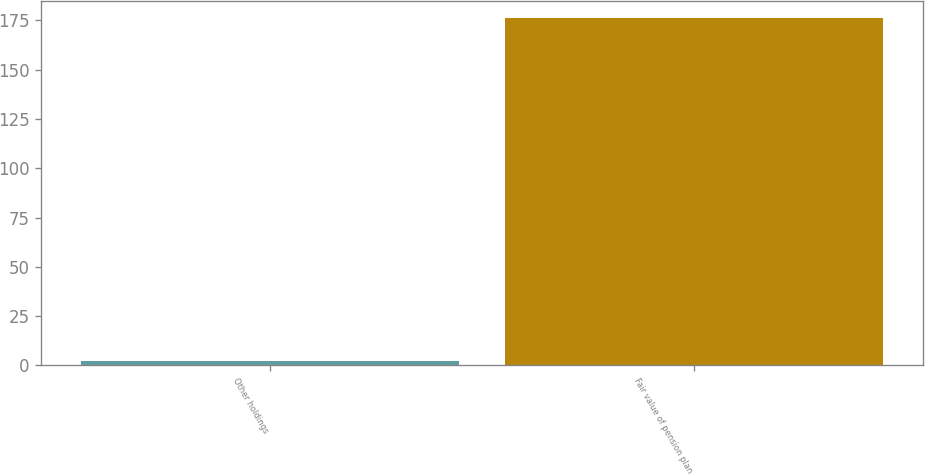Convert chart. <chart><loc_0><loc_0><loc_500><loc_500><bar_chart><fcel>Other holdings<fcel>Fair value of pension plan<nl><fcel>2<fcel>176<nl></chart> 